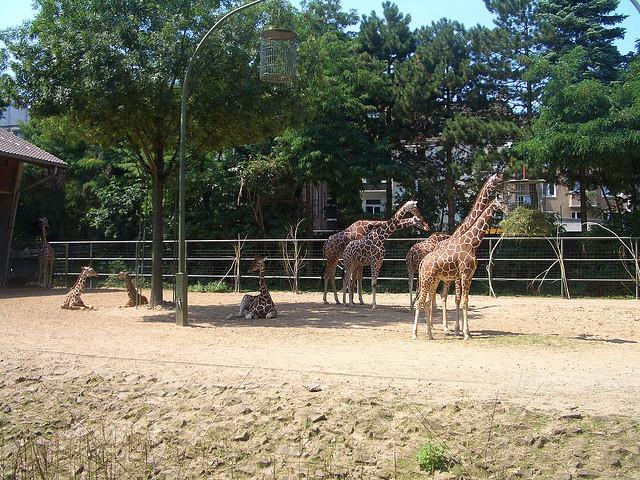What animals can be seen? Please explain your reasoning. giraffes. The other options aren't shown in this image. the long necks and spots make it obvious. 